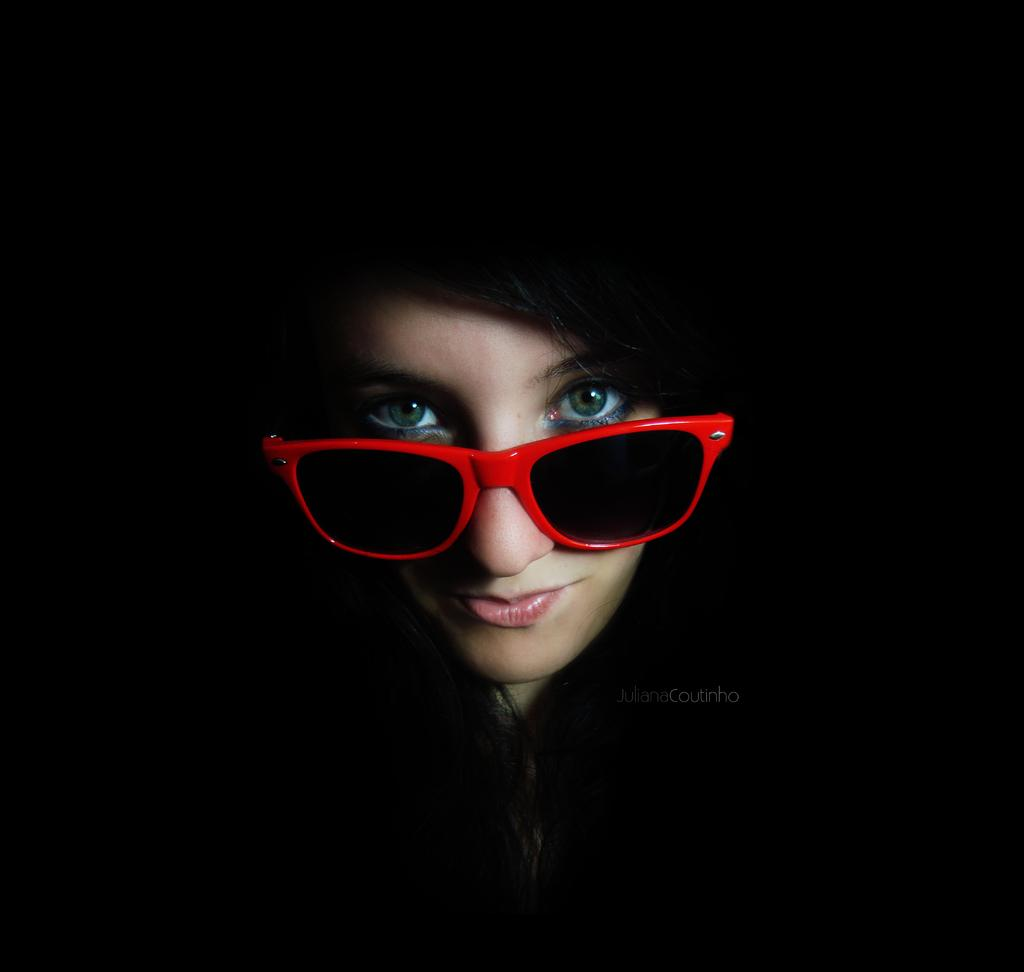Who is present in the image? There is a woman in the image. What accessory is the woman wearing in the image? The woman is wearing glasses in the image. What type of cloud is visible in the woman's face in the image? There is no cloud visible in the woman's face in the image, as the facts provided do not mention any clouds or facial features. 